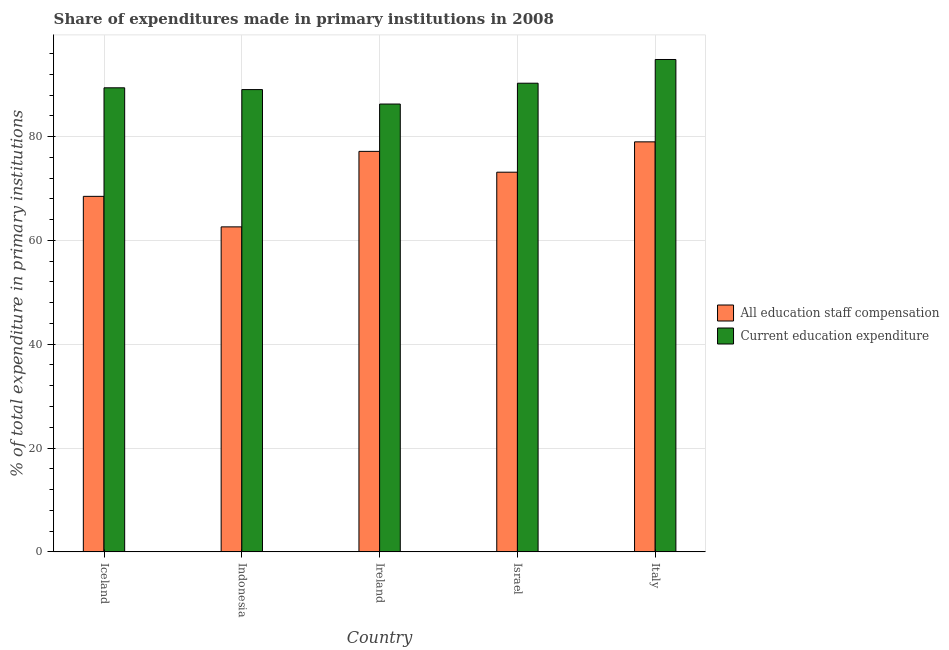How many groups of bars are there?
Ensure brevity in your answer.  5. Are the number of bars per tick equal to the number of legend labels?
Give a very brief answer. Yes. How many bars are there on the 5th tick from the left?
Provide a succinct answer. 2. What is the label of the 5th group of bars from the left?
Offer a very short reply. Italy. What is the expenditure in education in Israel?
Your answer should be very brief. 90.28. Across all countries, what is the maximum expenditure in education?
Your answer should be very brief. 94.85. Across all countries, what is the minimum expenditure in education?
Make the answer very short. 86.27. In which country was the expenditure in staff compensation minimum?
Keep it short and to the point. Indonesia. What is the total expenditure in staff compensation in the graph?
Keep it short and to the point. 360.37. What is the difference between the expenditure in staff compensation in Israel and that in Italy?
Provide a succinct answer. -5.85. What is the difference between the expenditure in education in Israel and the expenditure in staff compensation in Iceland?
Your answer should be compact. 21.79. What is the average expenditure in staff compensation per country?
Your answer should be compact. 72.07. What is the difference between the expenditure in staff compensation and expenditure in education in Iceland?
Keep it short and to the point. -20.91. What is the ratio of the expenditure in education in Israel to that in Italy?
Your response must be concise. 0.95. What is the difference between the highest and the second highest expenditure in education?
Make the answer very short. 4.57. What is the difference between the highest and the lowest expenditure in education?
Provide a short and direct response. 8.58. In how many countries, is the expenditure in staff compensation greater than the average expenditure in staff compensation taken over all countries?
Your answer should be compact. 3. What does the 1st bar from the left in Iceland represents?
Your answer should be very brief. All education staff compensation. What does the 1st bar from the right in Ireland represents?
Keep it short and to the point. Current education expenditure. How many bars are there?
Keep it short and to the point. 10. Are all the bars in the graph horizontal?
Offer a very short reply. No. What is the difference between two consecutive major ticks on the Y-axis?
Your answer should be very brief. 20. Does the graph contain any zero values?
Ensure brevity in your answer.  No. Does the graph contain grids?
Keep it short and to the point. Yes. How many legend labels are there?
Ensure brevity in your answer.  2. What is the title of the graph?
Make the answer very short. Share of expenditures made in primary institutions in 2008. What is the label or title of the X-axis?
Offer a terse response. Country. What is the label or title of the Y-axis?
Ensure brevity in your answer.  % of total expenditure in primary institutions. What is the % of total expenditure in primary institutions in All education staff compensation in Iceland?
Give a very brief answer. 68.49. What is the % of total expenditure in primary institutions in Current education expenditure in Iceland?
Keep it short and to the point. 89.4. What is the % of total expenditure in primary institutions of All education staff compensation in Indonesia?
Make the answer very short. 62.61. What is the % of total expenditure in primary institutions of Current education expenditure in Indonesia?
Your response must be concise. 89.06. What is the % of total expenditure in primary institutions in All education staff compensation in Ireland?
Provide a succinct answer. 77.15. What is the % of total expenditure in primary institutions of Current education expenditure in Ireland?
Keep it short and to the point. 86.27. What is the % of total expenditure in primary institutions in All education staff compensation in Israel?
Keep it short and to the point. 73.14. What is the % of total expenditure in primary institutions of Current education expenditure in Israel?
Keep it short and to the point. 90.28. What is the % of total expenditure in primary institutions of All education staff compensation in Italy?
Your answer should be very brief. 78.99. What is the % of total expenditure in primary institutions in Current education expenditure in Italy?
Offer a terse response. 94.85. Across all countries, what is the maximum % of total expenditure in primary institutions of All education staff compensation?
Provide a short and direct response. 78.99. Across all countries, what is the maximum % of total expenditure in primary institutions of Current education expenditure?
Ensure brevity in your answer.  94.85. Across all countries, what is the minimum % of total expenditure in primary institutions of All education staff compensation?
Give a very brief answer. 62.61. Across all countries, what is the minimum % of total expenditure in primary institutions in Current education expenditure?
Provide a short and direct response. 86.27. What is the total % of total expenditure in primary institutions of All education staff compensation in the graph?
Keep it short and to the point. 360.37. What is the total % of total expenditure in primary institutions in Current education expenditure in the graph?
Provide a succinct answer. 449.85. What is the difference between the % of total expenditure in primary institutions of All education staff compensation in Iceland and that in Indonesia?
Keep it short and to the point. 5.88. What is the difference between the % of total expenditure in primary institutions in Current education expenditure in Iceland and that in Indonesia?
Your answer should be compact. 0.34. What is the difference between the % of total expenditure in primary institutions of All education staff compensation in Iceland and that in Ireland?
Offer a very short reply. -8.67. What is the difference between the % of total expenditure in primary institutions of Current education expenditure in Iceland and that in Ireland?
Your answer should be compact. 3.13. What is the difference between the % of total expenditure in primary institutions of All education staff compensation in Iceland and that in Israel?
Your answer should be compact. -4.65. What is the difference between the % of total expenditure in primary institutions of Current education expenditure in Iceland and that in Israel?
Offer a terse response. -0.88. What is the difference between the % of total expenditure in primary institutions of All education staff compensation in Iceland and that in Italy?
Give a very brief answer. -10.5. What is the difference between the % of total expenditure in primary institutions of Current education expenditure in Iceland and that in Italy?
Keep it short and to the point. -5.45. What is the difference between the % of total expenditure in primary institutions of All education staff compensation in Indonesia and that in Ireland?
Ensure brevity in your answer.  -14.55. What is the difference between the % of total expenditure in primary institutions in Current education expenditure in Indonesia and that in Ireland?
Give a very brief answer. 2.79. What is the difference between the % of total expenditure in primary institutions of All education staff compensation in Indonesia and that in Israel?
Ensure brevity in your answer.  -10.53. What is the difference between the % of total expenditure in primary institutions of Current education expenditure in Indonesia and that in Israel?
Your answer should be very brief. -1.23. What is the difference between the % of total expenditure in primary institutions of All education staff compensation in Indonesia and that in Italy?
Keep it short and to the point. -16.38. What is the difference between the % of total expenditure in primary institutions in Current education expenditure in Indonesia and that in Italy?
Your answer should be very brief. -5.8. What is the difference between the % of total expenditure in primary institutions of All education staff compensation in Ireland and that in Israel?
Offer a very short reply. 4.01. What is the difference between the % of total expenditure in primary institutions in Current education expenditure in Ireland and that in Israel?
Keep it short and to the point. -4.01. What is the difference between the % of total expenditure in primary institutions of All education staff compensation in Ireland and that in Italy?
Offer a terse response. -1.83. What is the difference between the % of total expenditure in primary institutions of Current education expenditure in Ireland and that in Italy?
Your answer should be very brief. -8.58. What is the difference between the % of total expenditure in primary institutions in All education staff compensation in Israel and that in Italy?
Provide a succinct answer. -5.85. What is the difference between the % of total expenditure in primary institutions of Current education expenditure in Israel and that in Italy?
Ensure brevity in your answer.  -4.57. What is the difference between the % of total expenditure in primary institutions of All education staff compensation in Iceland and the % of total expenditure in primary institutions of Current education expenditure in Indonesia?
Ensure brevity in your answer.  -20.57. What is the difference between the % of total expenditure in primary institutions in All education staff compensation in Iceland and the % of total expenditure in primary institutions in Current education expenditure in Ireland?
Offer a very short reply. -17.78. What is the difference between the % of total expenditure in primary institutions of All education staff compensation in Iceland and the % of total expenditure in primary institutions of Current education expenditure in Israel?
Your answer should be compact. -21.79. What is the difference between the % of total expenditure in primary institutions of All education staff compensation in Iceland and the % of total expenditure in primary institutions of Current education expenditure in Italy?
Ensure brevity in your answer.  -26.36. What is the difference between the % of total expenditure in primary institutions in All education staff compensation in Indonesia and the % of total expenditure in primary institutions in Current education expenditure in Ireland?
Provide a succinct answer. -23.66. What is the difference between the % of total expenditure in primary institutions of All education staff compensation in Indonesia and the % of total expenditure in primary institutions of Current education expenditure in Israel?
Your answer should be very brief. -27.67. What is the difference between the % of total expenditure in primary institutions of All education staff compensation in Indonesia and the % of total expenditure in primary institutions of Current education expenditure in Italy?
Make the answer very short. -32.24. What is the difference between the % of total expenditure in primary institutions of All education staff compensation in Ireland and the % of total expenditure in primary institutions of Current education expenditure in Israel?
Offer a very short reply. -13.13. What is the difference between the % of total expenditure in primary institutions of All education staff compensation in Ireland and the % of total expenditure in primary institutions of Current education expenditure in Italy?
Keep it short and to the point. -17.7. What is the difference between the % of total expenditure in primary institutions of All education staff compensation in Israel and the % of total expenditure in primary institutions of Current education expenditure in Italy?
Your response must be concise. -21.71. What is the average % of total expenditure in primary institutions of All education staff compensation per country?
Offer a very short reply. 72.07. What is the average % of total expenditure in primary institutions of Current education expenditure per country?
Make the answer very short. 89.97. What is the difference between the % of total expenditure in primary institutions in All education staff compensation and % of total expenditure in primary institutions in Current education expenditure in Iceland?
Keep it short and to the point. -20.91. What is the difference between the % of total expenditure in primary institutions of All education staff compensation and % of total expenditure in primary institutions of Current education expenditure in Indonesia?
Ensure brevity in your answer.  -26.45. What is the difference between the % of total expenditure in primary institutions in All education staff compensation and % of total expenditure in primary institutions in Current education expenditure in Ireland?
Provide a short and direct response. -9.12. What is the difference between the % of total expenditure in primary institutions of All education staff compensation and % of total expenditure in primary institutions of Current education expenditure in Israel?
Provide a succinct answer. -17.14. What is the difference between the % of total expenditure in primary institutions in All education staff compensation and % of total expenditure in primary institutions in Current education expenditure in Italy?
Offer a very short reply. -15.87. What is the ratio of the % of total expenditure in primary institutions in All education staff compensation in Iceland to that in Indonesia?
Your answer should be very brief. 1.09. What is the ratio of the % of total expenditure in primary institutions in All education staff compensation in Iceland to that in Ireland?
Give a very brief answer. 0.89. What is the ratio of the % of total expenditure in primary institutions of Current education expenditure in Iceland to that in Ireland?
Give a very brief answer. 1.04. What is the ratio of the % of total expenditure in primary institutions in All education staff compensation in Iceland to that in Israel?
Your response must be concise. 0.94. What is the ratio of the % of total expenditure in primary institutions of Current education expenditure in Iceland to that in Israel?
Your response must be concise. 0.99. What is the ratio of the % of total expenditure in primary institutions in All education staff compensation in Iceland to that in Italy?
Provide a succinct answer. 0.87. What is the ratio of the % of total expenditure in primary institutions of Current education expenditure in Iceland to that in Italy?
Your response must be concise. 0.94. What is the ratio of the % of total expenditure in primary institutions in All education staff compensation in Indonesia to that in Ireland?
Provide a succinct answer. 0.81. What is the ratio of the % of total expenditure in primary institutions in Current education expenditure in Indonesia to that in Ireland?
Keep it short and to the point. 1.03. What is the ratio of the % of total expenditure in primary institutions of All education staff compensation in Indonesia to that in Israel?
Keep it short and to the point. 0.86. What is the ratio of the % of total expenditure in primary institutions of Current education expenditure in Indonesia to that in Israel?
Keep it short and to the point. 0.99. What is the ratio of the % of total expenditure in primary institutions in All education staff compensation in Indonesia to that in Italy?
Offer a terse response. 0.79. What is the ratio of the % of total expenditure in primary institutions of Current education expenditure in Indonesia to that in Italy?
Your answer should be very brief. 0.94. What is the ratio of the % of total expenditure in primary institutions in All education staff compensation in Ireland to that in Israel?
Provide a short and direct response. 1.05. What is the ratio of the % of total expenditure in primary institutions of Current education expenditure in Ireland to that in Israel?
Your response must be concise. 0.96. What is the ratio of the % of total expenditure in primary institutions of All education staff compensation in Ireland to that in Italy?
Offer a terse response. 0.98. What is the ratio of the % of total expenditure in primary institutions in Current education expenditure in Ireland to that in Italy?
Your answer should be compact. 0.91. What is the ratio of the % of total expenditure in primary institutions of All education staff compensation in Israel to that in Italy?
Your answer should be compact. 0.93. What is the ratio of the % of total expenditure in primary institutions of Current education expenditure in Israel to that in Italy?
Make the answer very short. 0.95. What is the difference between the highest and the second highest % of total expenditure in primary institutions of All education staff compensation?
Offer a terse response. 1.83. What is the difference between the highest and the second highest % of total expenditure in primary institutions of Current education expenditure?
Offer a very short reply. 4.57. What is the difference between the highest and the lowest % of total expenditure in primary institutions in All education staff compensation?
Your response must be concise. 16.38. What is the difference between the highest and the lowest % of total expenditure in primary institutions of Current education expenditure?
Provide a succinct answer. 8.58. 